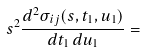<formula> <loc_0><loc_0><loc_500><loc_500>s ^ { 2 } \frac { d ^ { 2 } \sigma _ { i j } ( s , t _ { 1 } , u _ { 1 } ) } { d t _ { 1 } \, d u _ { 1 } } =</formula> 